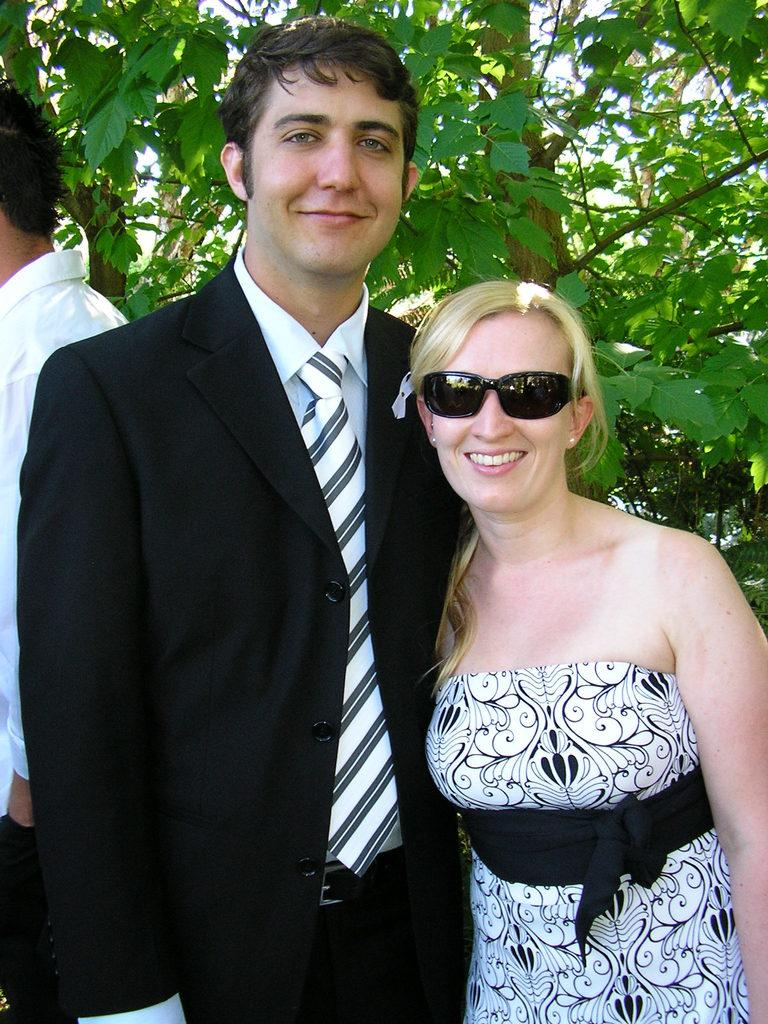What can be seen in the image? There are people standing in the image. What is visible in the background of the image? There are trees visible in the background of the image. What type of toys can be seen being played with in the image? There are no toys visible in the image; it only features people standing and trees in the background. 